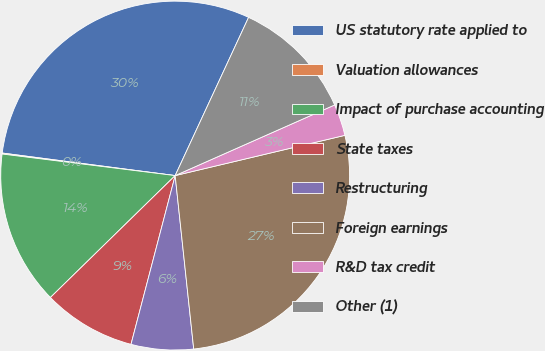Convert chart to OTSL. <chart><loc_0><loc_0><loc_500><loc_500><pie_chart><fcel>US statutory rate applied to<fcel>Valuation allowances<fcel>Impact of purchase accounting<fcel>State taxes<fcel>Restructuring<fcel>Foreign earnings<fcel>R&D tax credit<fcel>Other (1)<nl><fcel>29.85%<fcel>0.09%<fcel>14.29%<fcel>8.61%<fcel>5.77%<fcel>27.01%<fcel>2.93%<fcel>11.45%<nl></chart> 